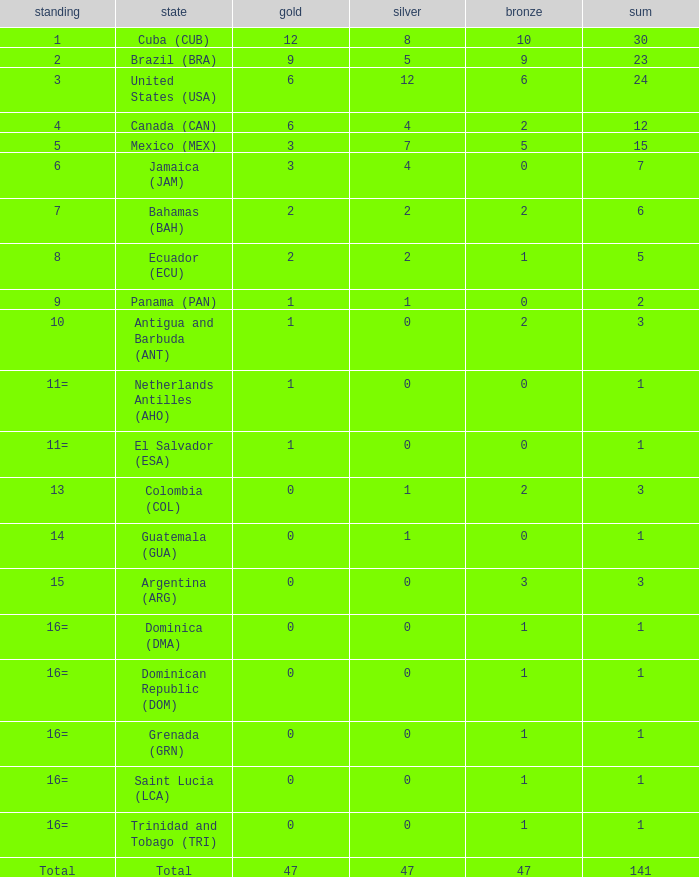How many bronzes have a Nation of jamaica (jam), and a Total smaller than 7? 0.0. 